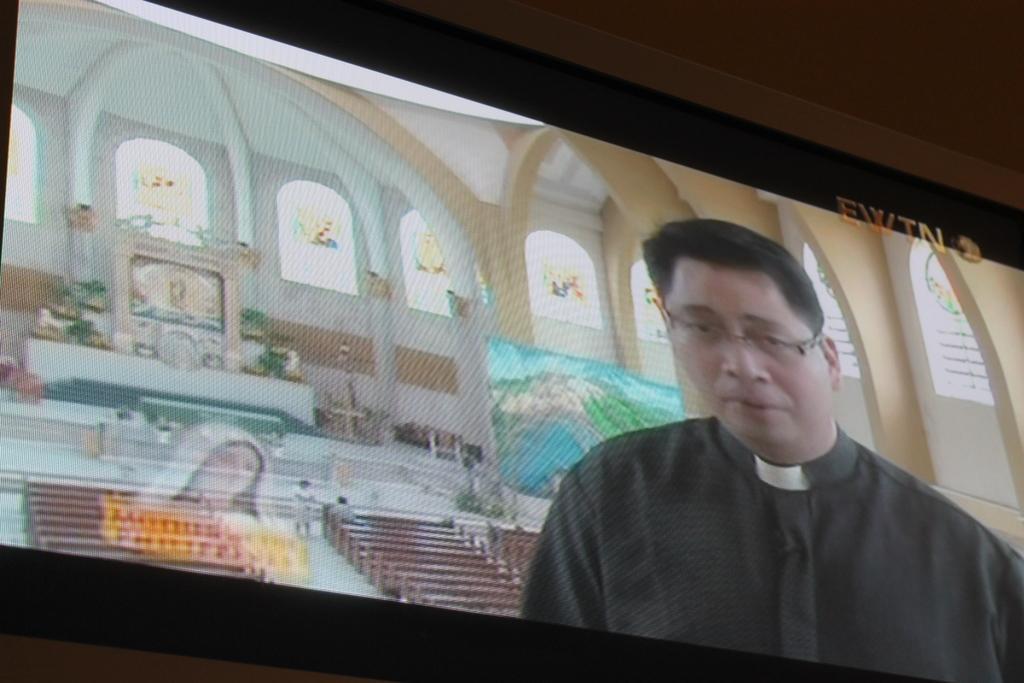Can you describe this image briefly? In this image I can see a television in which I can see a person in the front, there are benches, sculptures and stained glasses behind him. 